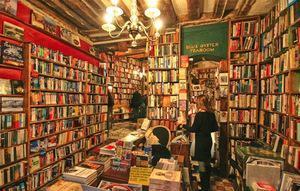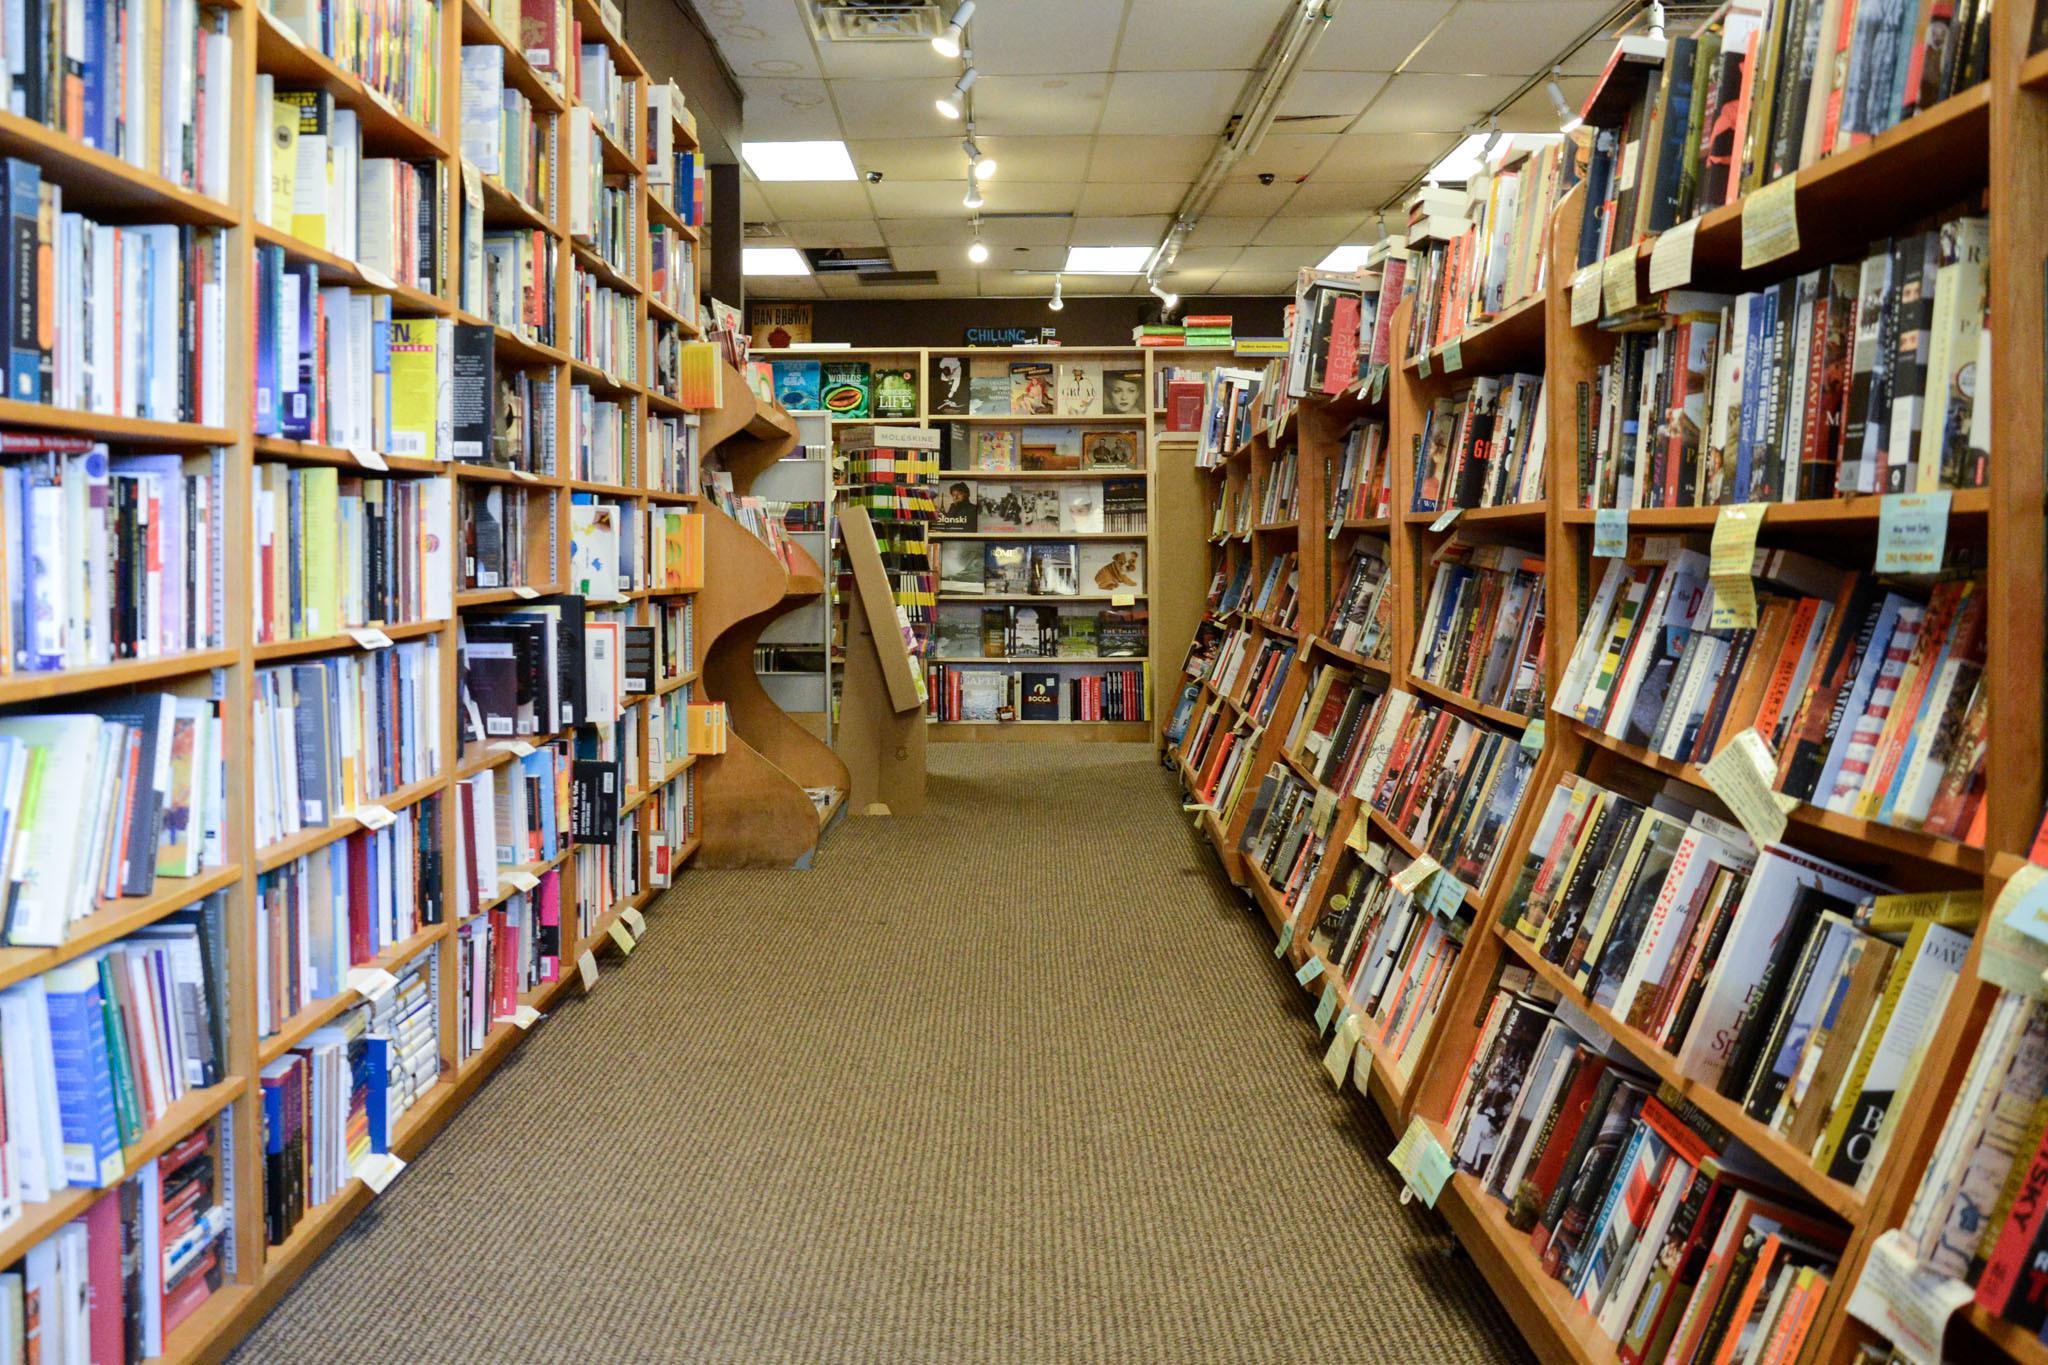The first image is the image on the left, the second image is the image on the right. For the images displayed, is the sentence "One image is straight down an uncluttered, carpeted aisle with books shelved on both sides." factually correct? Answer yes or no. Yes. 